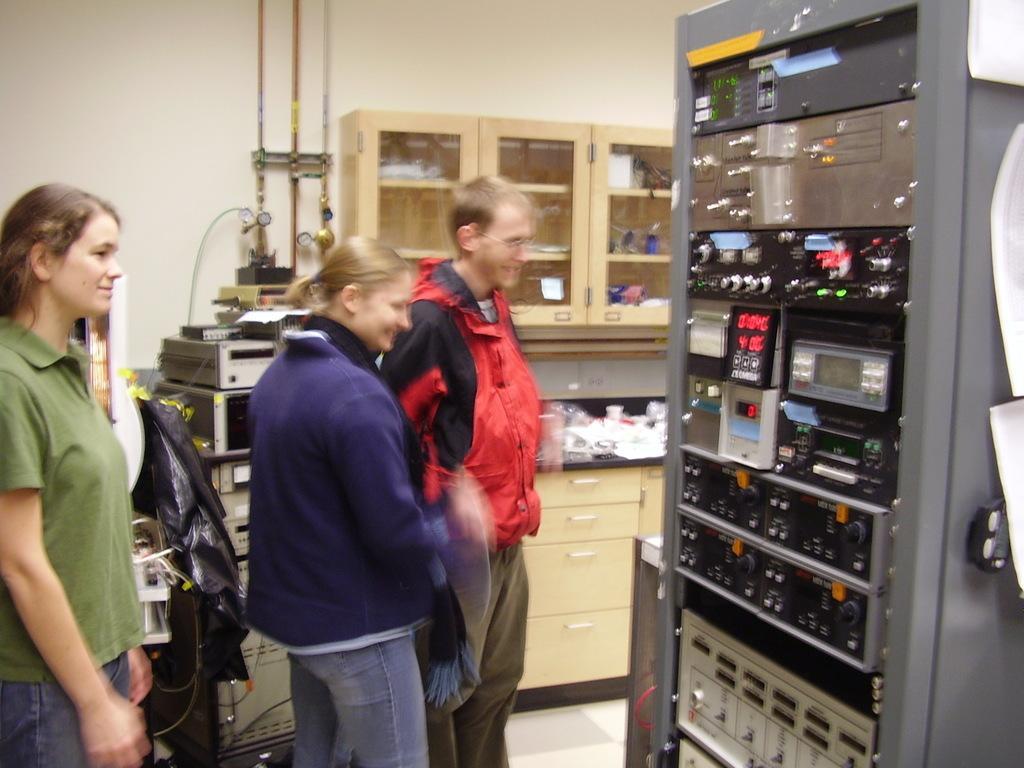Please provide a concise description of this image. In this image i can a see few people, on the right there is an object, near that i can see cupboard and few objects in it, beside there are few objects. 